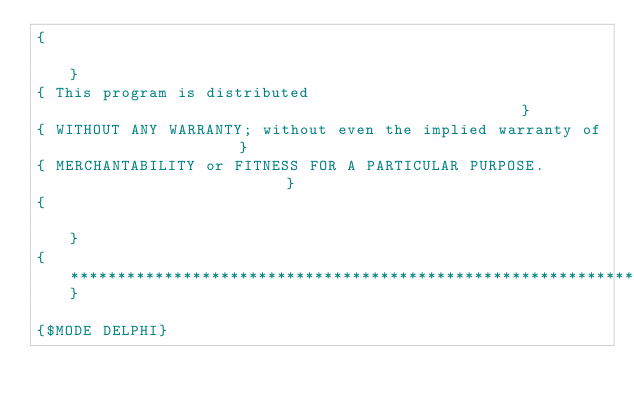Convert code to text. <code><loc_0><loc_0><loc_500><loc_500><_Pascal_>{                                                                             }
{ This program is distributed                                                 }
{ WITHOUT ANY WARRANTY; without even the implied warranty of                  }
{ MERCHANTABILITY or FITNESS FOR A PARTICULAR PURPOSE.                        }
{                                                                             }
{*****************************************************************************}

{$MODE DELPHI}</code> 